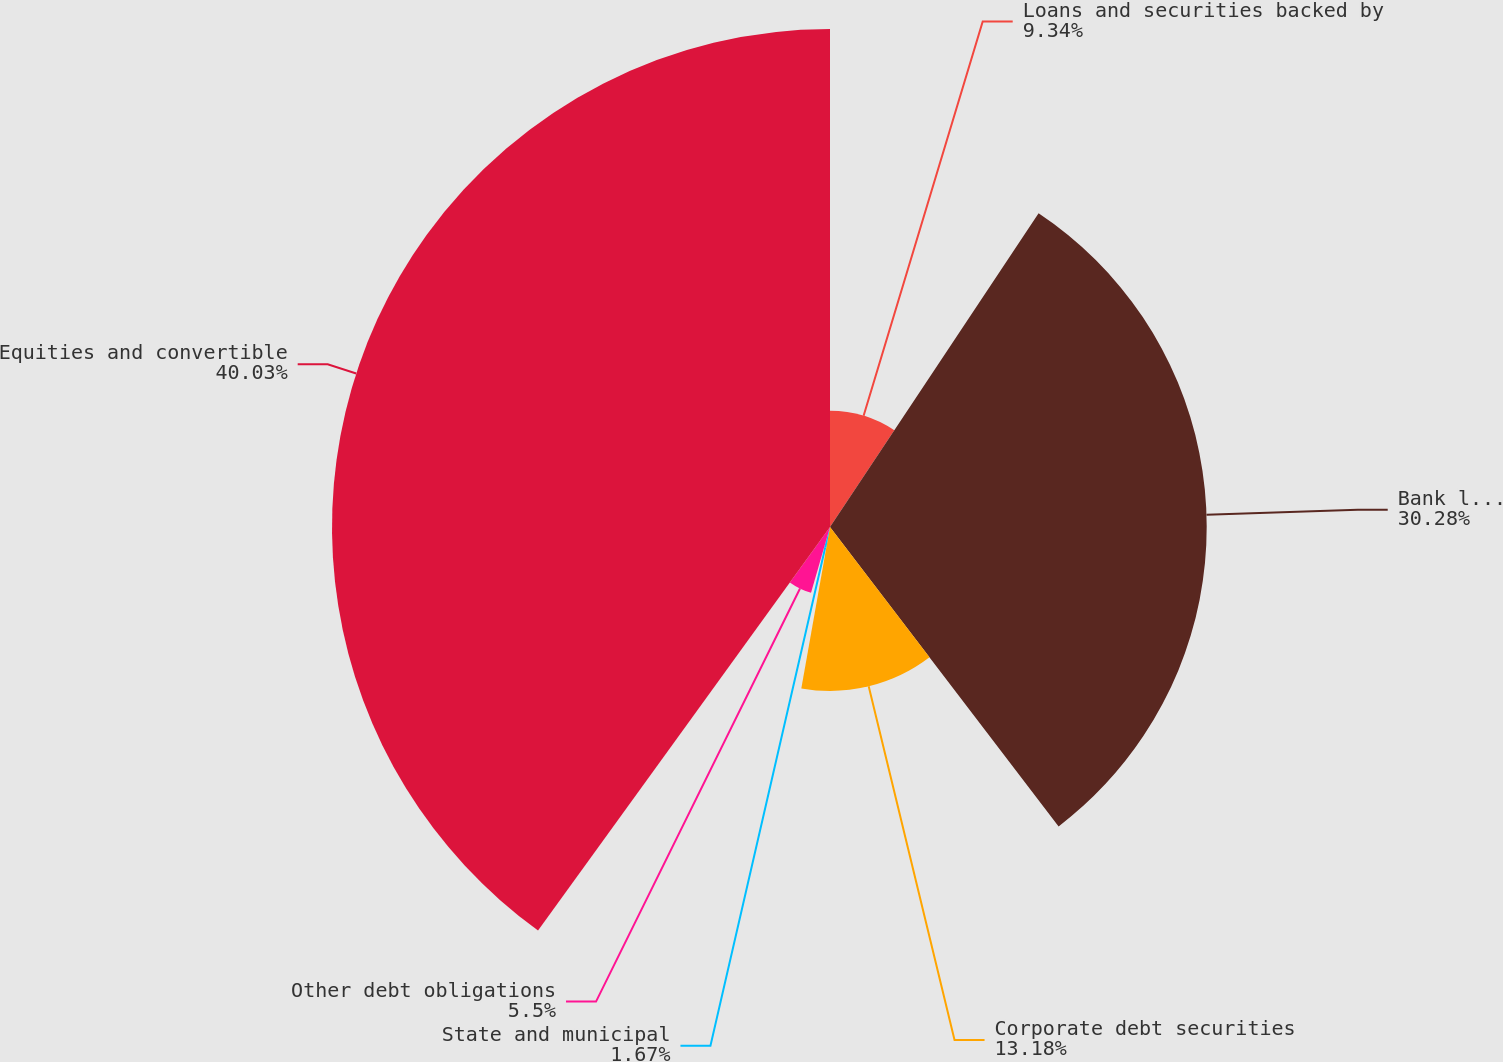Convert chart. <chart><loc_0><loc_0><loc_500><loc_500><pie_chart><fcel>Loans and securities backed by<fcel>Bank loans and bridge loans<fcel>Corporate debt securities<fcel>State and municipal<fcel>Other debt obligations<fcel>Equities and convertible<nl><fcel>9.34%<fcel>30.28%<fcel>13.18%<fcel>1.67%<fcel>5.5%<fcel>40.03%<nl></chart> 